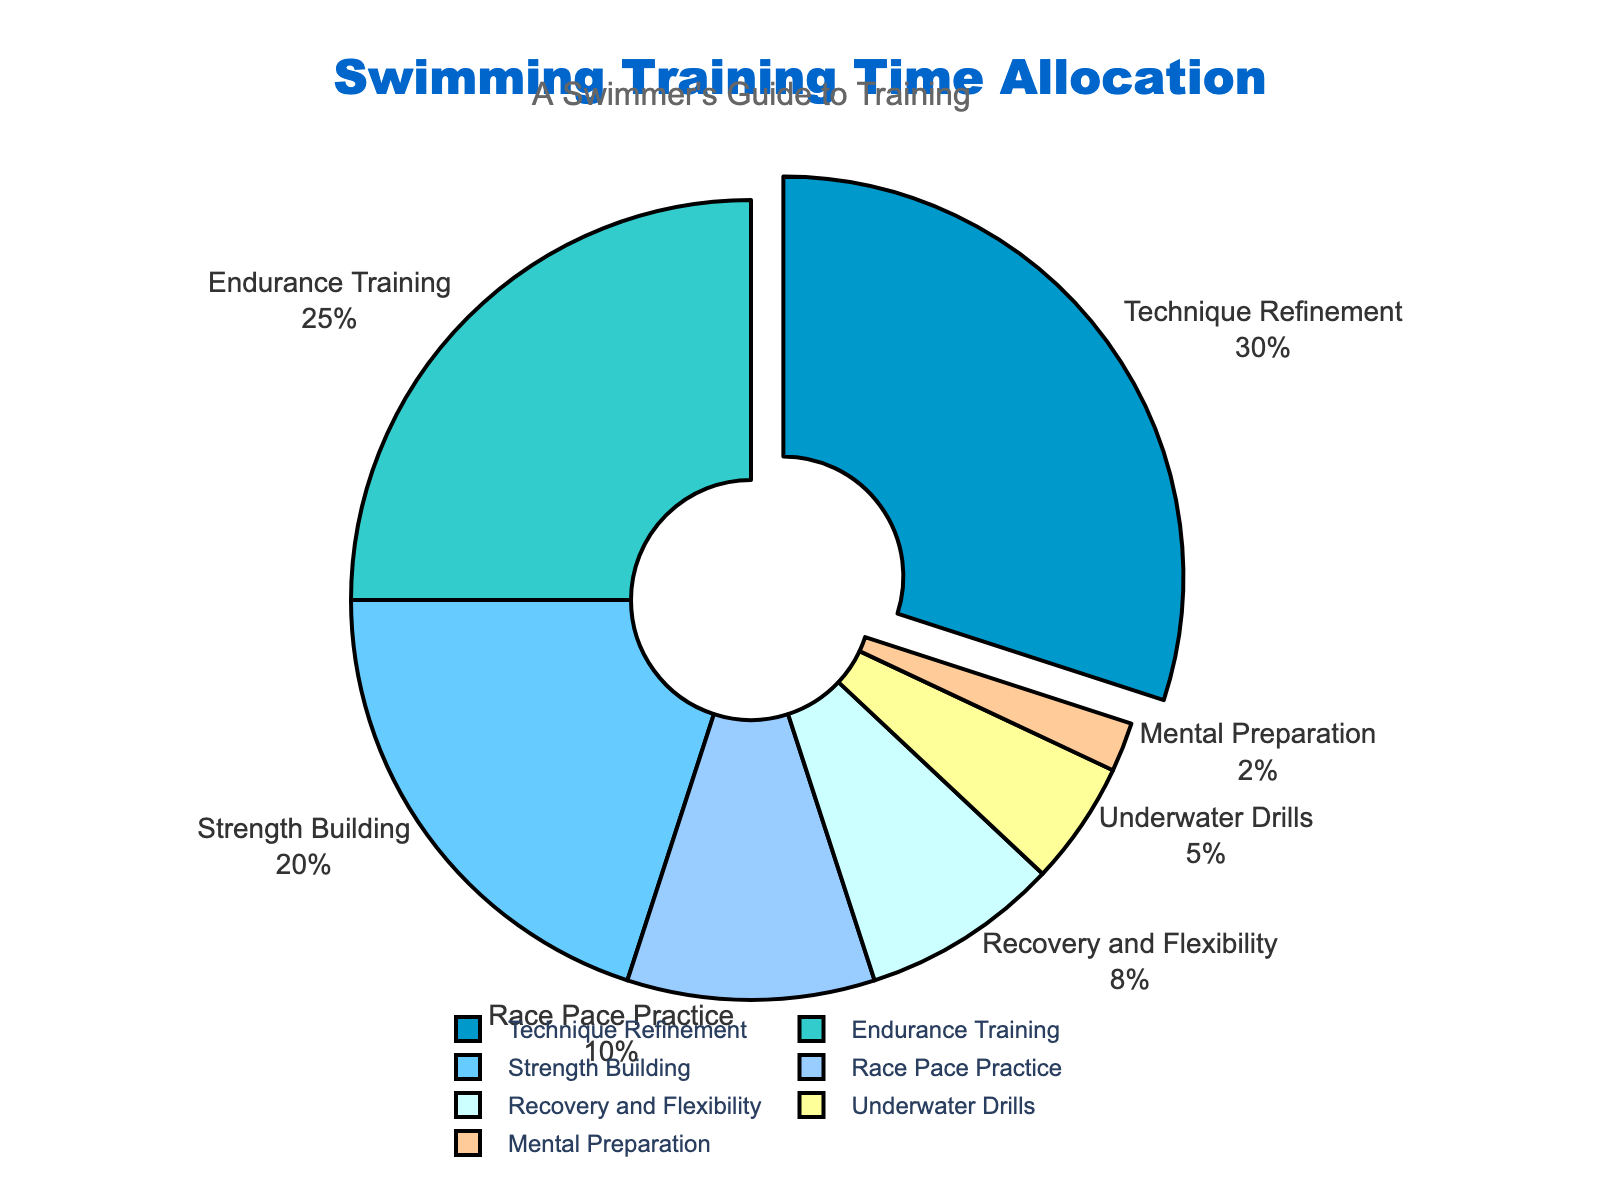How much time is allocated to Technique Refinement and Endurance Training combined? Technique Refinement is 30% and Endurance Training is 25%. Adding these two percentages together: 30 + 25 = 55%
Answer: 55% Which aspect has the least allocated time? From the chart, Mental Preparation has the smallest slice at 2%.
Answer: Mental Preparation How many times larger is the percentage for Technique Refinement compared to Underwater Drills? Technique Refinement is 30% and Underwater Drills is 5%. To find how many times larger: 30 / 5 = 6
Answer: 6 Which aspect is second highest in allocation after Technique Refinement? Technique Refinement is highest at 30%, the second highest is Endurance Training at 25%.
Answer: Endurance Training What is the difference in time allocation between Strength Building and Race Pace Practice? Strength Building is 20% and Race Pace Practice is 10%. The difference is: 20 - 10 = 10%
Answer: 10% Is the combined allocation of Recovery and Flexibility and Underwater Drills greater than the allocation for Strength Building? Recovery and Flexibility is 8% and Underwater Drills is 5%. Combined: 8 + 5 = 13%. Strength Building is 20%. Since 13% is less than 20%, the combined allocation is not greater.
Answer: No If you were to group Technique Refinement, Endurance Training, and Strength Building, what would be the total time allocation? Technique Refinement is 30%, Endurance Training is 25%, and Strength Building is 20%. Total: 30 + 25 + 20 = 75%
Answer: 75% Which aspect is allocated more time: Recovery and Flexibility or Mental Preparation? Recovery and Flexibility is 8% while Mental Preparation is just 2%. 8% is greater than 2%.
Answer: Recovery and Flexibility 